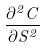<formula> <loc_0><loc_0><loc_500><loc_500>\frac { \partial ^ { 2 } C } { \partial S ^ { 2 } }</formula> 